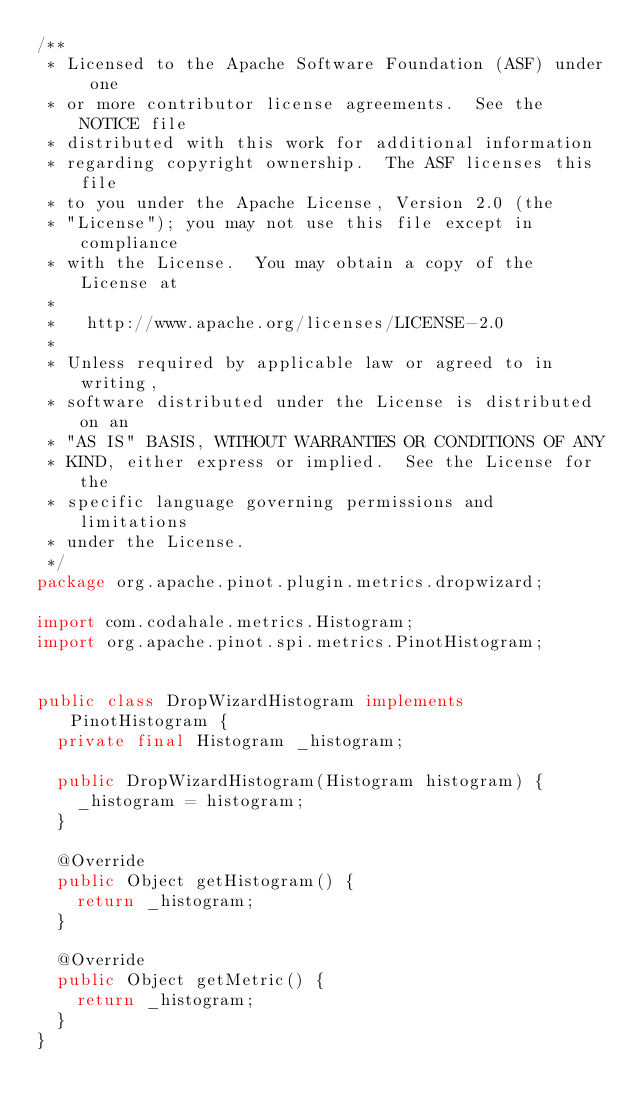Convert code to text. <code><loc_0><loc_0><loc_500><loc_500><_Java_>/**
 * Licensed to the Apache Software Foundation (ASF) under one
 * or more contributor license agreements.  See the NOTICE file
 * distributed with this work for additional information
 * regarding copyright ownership.  The ASF licenses this file
 * to you under the Apache License, Version 2.0 (the
 * "License"); you may not use this file except in compliance
 * with the License.  You may obtain a copy of the License at
 *
 *   http://www.apache.org/licenses/LICENSE-2.0
 *
 * Unless required by applicable law or agreed to in writing,
 * software distributed under the License is distributed on an
 * "AS IS" BASIS, WITHOUT WARRANTIES OR CONDITIONS OF ANY
 * KIND, either express or implied.  See the License for the
 * specific language governing permissions and limitations
 * under the License.
 */
package org.apache.pinot.plugin.metrics.dropwizard;

import com.codahale.metrics.Histogram;
import org.apache.pinot.spi.metrics.PinotHistogram;


public class DropWizardHistogram implements PinotHistogram {
  private final Histogram _histogram;

  public DropWizardHistogram(Histogram histogram) {
    _histogram = histogram;
  }

  @Override
  public Object getHistogram() {
    return _histogram;
  }

  @Override
  public Object getMetric() {
    return _histogram;
  }
}
</code> 